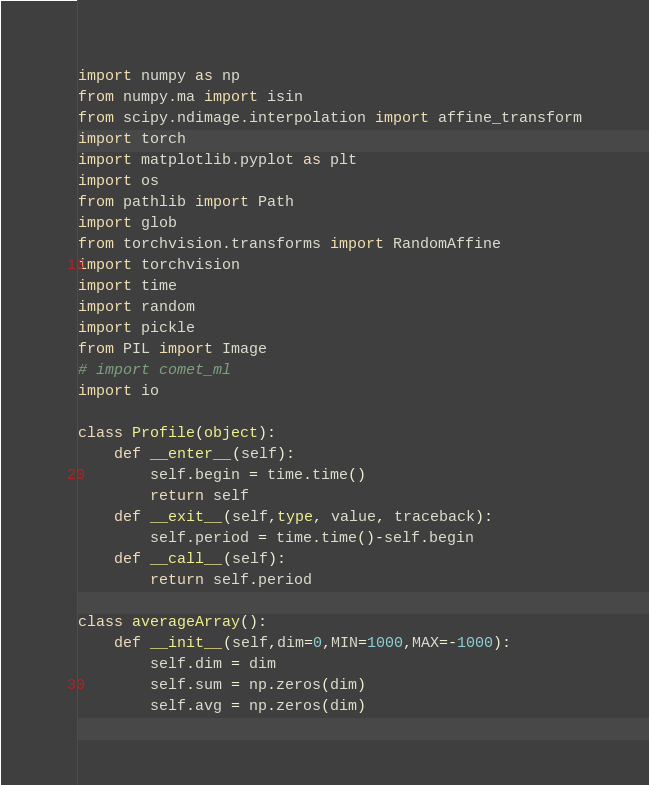<code> <loc_0><loc_0><loc_500><loc_500><_Python_>import numpy as np
from numpy.ma import isin
from scipy.ndimage.interpolation import affine_transform
import torch
import matplotlib.pyplot as plt
import os
from pathlib import Path
import glob
from torchvision.transforms import RandomAffine
import torchvision
import time
import random
import pickle
from PIL import Image
# import comet_ml
import io

class Profile(object):
    def __enter__(self):
        self.begin = time.time()
        return self
    def __exit__(self,type, value, traceback):
        self.period = time.time()-self.begin
    def __call__(self):
        return self.period

class averageArray():
    def __init__(self,dim=0,MIN=1000,MAX=-1000):
        self.dim = dim
        self.sum = np.zeros(dim)
        self.avg = np.zeros(dim)</code> 